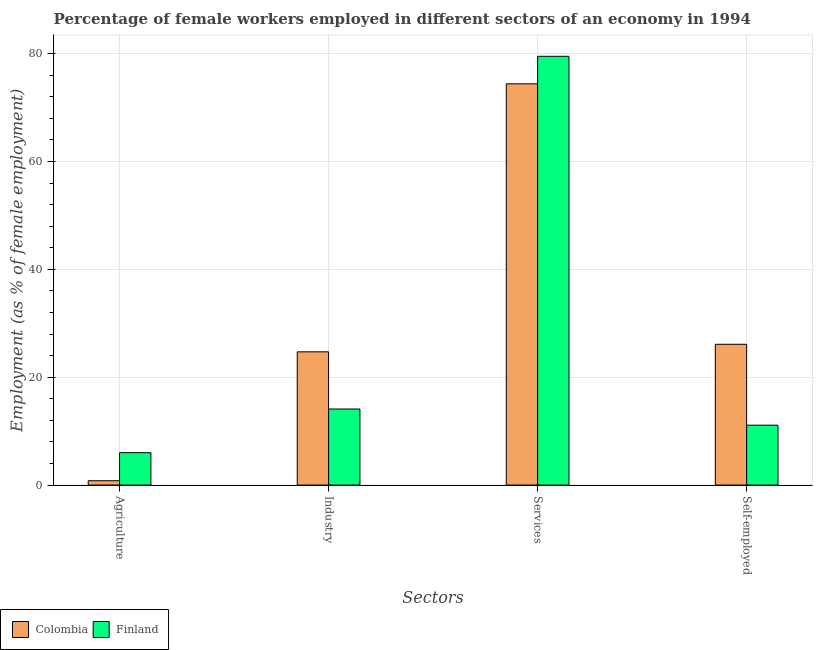Are the number of bars on each tick of the X-axis equal?
Your response must be concise. Yes. How many bars are there on the 3rd tick from the right?
Offer a terse response. 2. What is the label of the 2nd group of bars from the left?
Provide a short and direct response. Industry. What is the percentage of female workers in industry in Colombia?
Offer a very short reply. 24.7. Across all countries, what is the maximum percentage of female workers in industry?
Provide a short and direct response. 24.7. Across all countries, what is the minimum percentage of female workers in services?
Your answer should be very brief. 74.4. What is the total percentage of female workers in industry in the graph?
Your answer should be very brief. 38.8. What is the difference between the percentage of female workers in services in Finland and that in Colombia?
Offer a terse response. 5.1. What is the difference between the percentage of female workers in agriculture in Colombia and the percentage of female workers in services in Finland?
Your answer should be compact. -78.7. What is the average percentage of female workers in services per country?
Provide a short and direct response. 76.95. What is the difference between the percentage of self employed female workers and percentage of female workers in agriculture in Colombia?
Ensure brevity in your answer.  25.3. In how many countries, is the percentage of female workers in agriculture greater than 20 %?
Offer a very short reply. 0. What is the ratio of the percentage of female workers in services in Finland to that in Colombia?
Keep it short and to the point. 1.07. Is the percentage of female workers in industry in Finland less than that in Colombia?
Give a very brief answer. Yes. Is the difference between the percentage of female workers in services in Colombia and Finland greater than the difference between the percentage of female workers in industry in Colombia and Finland?
Make the answer very short. No. What is the difference between the highest and the second highest percentage of self employed female workers?
Your response must be concise. 15. What is the difference between the highest and the lowest percentage of female workers in industry?
Keep it short and to the point. 10.6. In how many countries, is the percentage of female workers in agriculture greater than the average percentage of female workers in agriculture taken over all countries?
Give a very brief answer. 1. What does the 1st bar from the right in Services represents?
Offer a very short reply. Finland. Is it the case that in every country, the sum of the percentage of female workers in agriculture and percentage of female workers in industry is greater than the percentage of female workers in services?
Offer a very short reply. No. How many countries are there in the graph?
Make the answer very short. 2. Are the values on the major ticks of Y-axis written in scientific E-notation?
Make the answer very short. No. Does the graph contain grids?
Provide a short and direct response. Yes. What is the title of the graph?
Provide a succinct answer. Percentage of female workers employed in different sectors of an economy in 1994. What is the label or title of the X-axis?
Provide a short and direct response. Sectors. What is the label or title of the Y-axis?
Make the answer very short. Employment (as % of female employment). What is the Employment (as % of female employment) of Colombia in Agriculture?
Provide a short and direct response. 0.8. What is the Employment (as % of female employment) of Colombia in Industry?
Keep it short and to the point. 24.7. What is the Employment (as % of female employment) in Finland in Industry?
Your answer should be compact. 14.1. What is the Employment (as % of female employment) in Colombia in Services?
Provide a short and direct response. 74.4. What is the Employment (as % of female employment) of Finland in Services?
Provide a short and direct response. 79.5. What is the Employment (as % of female employment) of Colombia in Self-employed?
Give a very brief answer. 26.1. What is the Employment (as % of female employment) of Finland in Self-employed?
Provide a succinct answer. 11.1. Across all Sectors, what is the maximum Employment (as % of female employment) in Colombia?
Your answer should be compact. 74.4. Across all Sectors, what is the maximum Employment (as % of female employment) in Finland?
Provide a succinct answer. 79.5. Across all Sectors, what is the minimum Employment (as % of female employment) in Colombia?
Your response must be concise. 0.8. Across all Sectors, what is the minimum Employment (as % of female employment) in Finland?
Give a very brief answer. 6. What is the total Employment (as % of female employment) of Colombia in the graph?
Offer a terse response. 126. What is the total Employment (as % of female employment) of Finland in the graph?
Offer a terse response. 110.7. What is the difference between the Employment (as % of female employment) in Colombia in Agriculture and that in Industry?
Keep it short and to the point. -23.9. What is the difference between the Employment (as % of female employment) in Finland in Agriculture and that in Industry?
Ensure brevity in your answer.  -8.1. What is the difference between the Employment (as % of female employment) of Colombia in Agriculture and that in Services?
Keep it short and to the point. -73.6. What is the difference between the Employment (as % of female employment) in Finland in Agriculture and that in Services?
Make the answer very short. -73.5. What is the difference between the Employment (as % of female employment) in Colombia in Agriculture and that in Self-employed?
Keep it short and to the point. -25.3. What is the difference between the Employment (as % of female employment) of Finland in Agriculture and that in Self-employed?
Provide a short and direct response. -5.1. What is the difference between the Employment (as % of female employment) in Colombia in Industry and that in Services?
Ensure brevity in your answer.  -49.7. What is the difference between the Employment (as % of female employment) of Finland in Industry and that in Services?
Give a very brief answer. -65.4. What is the difference between the Employment (as % of female employment) in Colombia in Industry and that in Self-employed?
Keep it short and to the point. -1.4. What is the difference between the Employment (as % of female employment) of Finland in Industry and that in Self-employed?
Your response must be concise. 3. What is the difference between the Employment (as % of female employment) of Colombia in Services and that in Self-employed?
Your answer should be compact. 48.3. What is the difference between the Employment (as % of female employment) in Finland in Services and that in Self-employed?
Offer a terse response. 68.4. What is the difference between the Employment (as % of female employment) of Colombia in Agriculture and the Employment (as % of female employment) of Finland in Industry?
Provide a succinct answer. -13.3. What is the difference between the Employment (as % of female employment) of Colombia in Agriculture and the Employment (as % of female employment) of Finland in Services?
Offer a very short reply. -78.7. What is the difference between the Employment (as % of female employment) of Colombia in Agriculture and the Employment (as % of female employment) of Finland in Self-employed?
Provide a short and direct response. -10.3. What is the difference between the Employment (as % of female employment) in Colombia in Industry and the Employment (as % of female employment) in Finland in Services?
Provide a succinct answer. -54.8. What is the difference between the Employment (as % of female employment) of Colombia in Services and the Employment (as % of female employment) of Finland in Self-employed?
Offer a terse response. 63.3. What is the average Employment (as % of female employment) in Colombia per Sectors?
Your response must be concise. 31.5. What is the average Employment (as % of female employment) of Finland per Sectors?
Your answer should be very brief. 27.68. What is the difference between the Employment (as % of female employment) in Colombia and Employment (as % of female employment) in Finland in Industry?
Give a very brief answer. 10.6. What is the difference between the Employment (as % of female employment) in Colombia and Employment (as % of female employment) in Finland in Services?
Make the answer very short. -5.1. What is the difference between the Employment (as % of female employment) in Colombia and Employment (as % of female employment) in Finland in Self-employed?
Your answer should be very brief. 15. What is the ratio of the Employment (as % of female employment) in Colombia in Agriculture to that in Industry?
Offer a terse response. 0.03. What is the ratio of the Employment (as % of female employment) in Finland in Agriculture to that in Industry?
Your answer should be very brief. 0.43. What is the ratio of the Employment (as % of female employment) in Colombia in Agriculture to that in Services?
Ensure brevity in your answer.  0.01. What is the ratio of the Employment (as % of female employment) of Finland in Agriculture to that in Services?
Your answer should be very brief. 0.08. What is the ratio of the Employment (as % of female employment) of Colombia in Agriculture to that in Self-employed?
Offer a very short reply. 0.03. What is the ratio of the Employment (as % of female employment) in Finland in Agriculture to that in Self-employed?
Provide a succinct answer. 0.54. What is the ratio of the Employment (as % of female employment) of Colombia in Industry to that in Services?
Your response must be concise. 0.33. What is the ratio of the Employment (as % of female employment) of Finland in Industry to that in Services?
Offer a very short reply. 0.18. What is the ratio of the Employment (as % of female employment) of Colombia in Industry to that in Self-employed?
Give a very brief answer. 0.95. What is the ratio of the Employment (as % of female employment) in Finland in Industry to that in Self-employed?
Your answer should be compact. 1.27. What is the ratio of the Employment (as % of female employment) in Colombia in Services to that in Self-employed?
Your answer should be very brief. 2.85. What is the ratio of the Employment (as % of female employment) of Finland in Services to that in Self-employed?
Your answer should be very brief. 7.16. What is the difference between the highest and the second highest Employment (as % of female employment) in Colombia?
Offer a very short reply. 48.3. What is the difference between the highest and the second highest Employment (as % of female employment) of Finland?
Keep it short and to the point. 65.4. What is the difference between the highest and the lowest Employment (as % of female employment) of Colombia?
Your response must be concise. 73.6. What is the difference between the highest and the lowest Employment (as % of female employment) of Finland?
Provide a succinct answer. 73.5. 